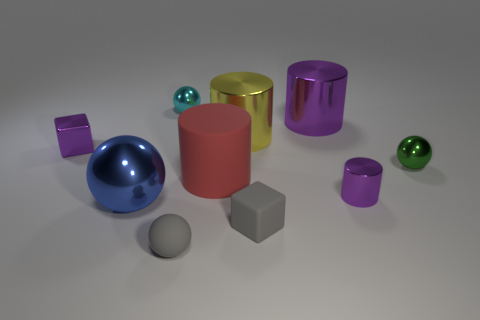Is there a gray sphere made of the same material as the cyan ball?
Provide a succinct answer. No. What is the material of the purple cylinder to the right of the big shiny cylinder on the right side of the gray cube?
Your answer should be very brief. Metal. How many big purple metal things have the same shape as the large red thing?
Your response must be concise. 1. There is a big yellow thing; what shape is it?
Offer a terse response. Cylinder. Is the number of small things less than the number of matte objects?
Your answer should be compact. No. Are there any other things that are the same size as the blue metallic ball?
Give a very brief answer. Yes. What material is the other purple object that is the same shape as the big purple thing?
Give a very brief answer. Metal. Are there more tiny green metal things than cyan blocks?
Offer a very short reply. Yes. How many other objects are there of the same color as the big matte object?
Provide a short and direct response. 0. Does the small purple block have the same material as the purple cylinder behind the red cylinder?
Keep it short and to the point. Yes. 